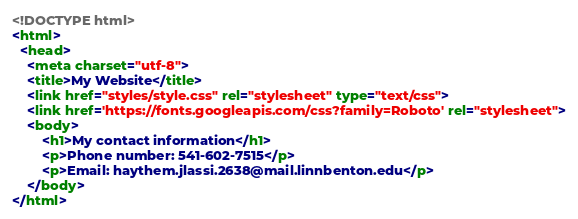Convert code to text. <code><loc_0><loc_0><loc_500><loc_500><_HTML_><!DOCTYPE html>
<html>
  <head>
    <meta charset="utf-8">
    <title>My Website</title>
    <link href="styles/style.css" rel="stylesheet" type="text/css">
    <link href='https://fonts.googleapis.com/css?family=Roboto' rel="stylesheet">
    <body>
        <h1>My contact information</h1>
        <p>Phone number: 541-602-7515</p>
        <p>Email: haythem.jlassi.2638@mail.linnbenton.edu</p>
    </body>
</html></code> 